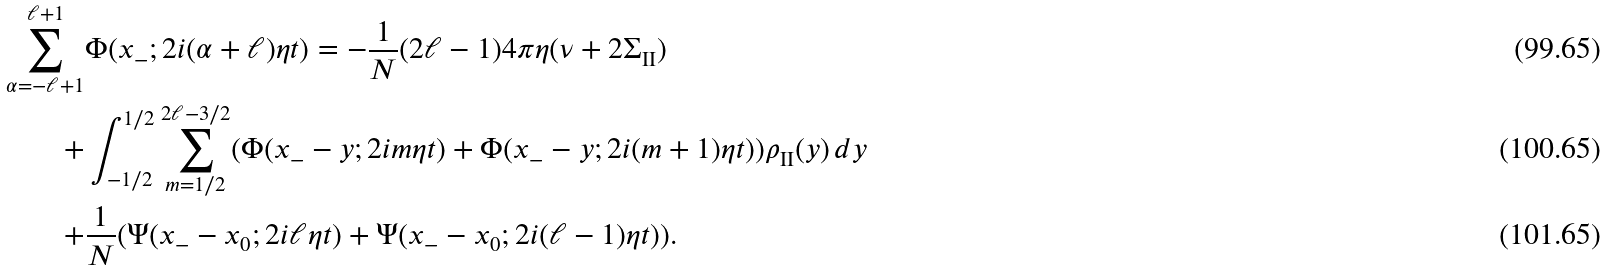<formula> <loc_0><loc_0><loc_500><loc_500>\sum _ { \alpha = - \ell + 1 } ^ { \ell + 1 } & \Phi ( x _ { - } ; 2 i ( \alpha + \ell ) \eta t ) = - \frac { 1 } { N } ( 2 \ell - 1 ) 4 \pi \eta ( \nu + 2 \Sigma _ { \text {II} } ) \\ + & \int _ { - 1 / 2 } ^ { 1 / 2 } \sum _ { m = 1 / 2 } ^ { 2 \ell - 3 / 2 } ( \Phi ( x _ { - } - y ; 2 i m \eta t ) + \Phi ( x _ { - } - y ; 2 i ( m + 1 ) \eta t ) ) \rho _ { \text {II} } ( y ) \, d y \\ + & \frac { 1 } { N } ( \Psi ( x _ { - } - x _ { 0 } ; 2 i \ell \eta t ) + \Psi ( x _ { - } - x _ { 0 } ; 2 i ( \ell - 1 ) \eta t ) ) .</formula> 